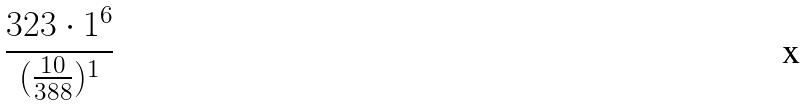<formula> <loc_0><loc_0><loc_500><loc_500>\frac { 3 2 3 \cdot 1 ^ { 6 } } { ( \frac { 1 0 } { 3 8 8 } ) ^ { 1 } }</formula> 